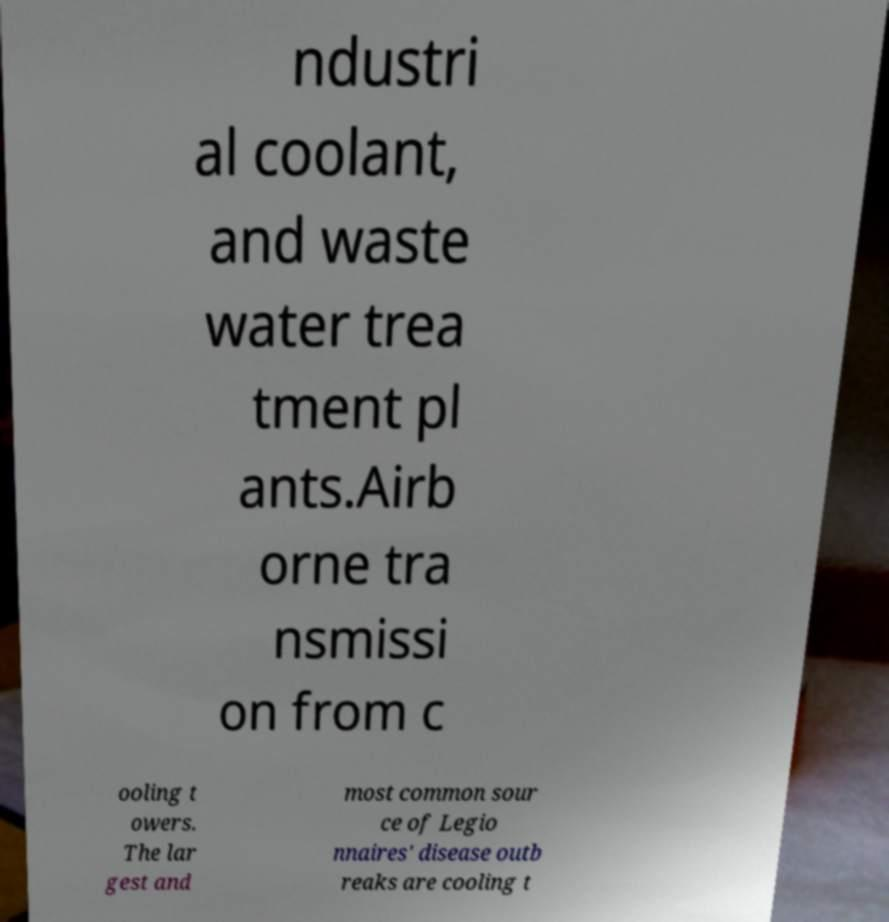Can you accurately transcribe the text from the provided image for me? ndustri al coolant, and waste water trea tment pl ants.Airb orne tra nsmissi on from c ooling t owers. The lar gest and most common sour ce of Legio nnaires' disease outb reaks are cooling t 